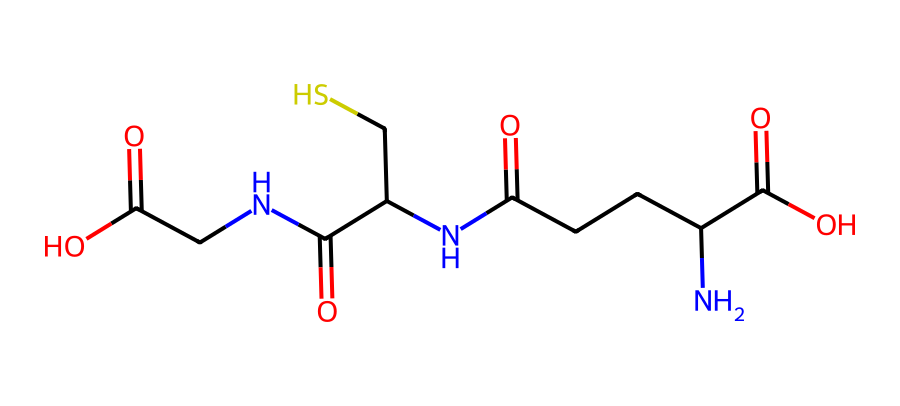What is the molecular formula of glutathione? By analyzing the structure represented by the SMILES, we can count the various types of atoms present: Carbon (C), Hydrogen (H), Nitrogen (N), Oxygen (O), and Sulfur (S). The total counts lead us to deduce the molecular formula.
Answer: C10H17N3O6S How many nitrogen atoms are present in glutathione? The structure includes three distinct nitrogen (N) atoms, identifiable from the amine functional groups.
Answer: 3 What type of functional groups are present in glutathione? Upon inspecting the structure, one can identify amine (-NH) groups and carboxylic acid (-COOH) groups, which are indicated by the presence of nitrogen and carbonyl oxygens connected to hydroxyl functions.
Answer: amine and carboxylic acid How many carbon atoms does glutathione contain? Counting the carbon (C) atoms in the structure reveals a total of ten carbon atoms, which can be visually confirmed in the chemical diagram derived from the SMILES representation.
Answer: 10 Is glutathione a peptide or a small protein? Glutathione is classified as a tripeptide, formed by the linkage of three amino acids through peptide bonds, which is characteristic of small proteins.
Answer: tripeptide What is the significance of sulfur in glutathione? The sulfur atom plays a crucial role in the antioxidant function of glutathione, enabling the formation of disulfide bonds, which are critical in redox reactions that protect cells from oxidative stress.
Answer: antioxidant function What is the primary antioxidant function of glutathione? Glutathione primarily acts to neutralize free radicals, thus preventing cellular damage caused by oxidative stress and maintaining redox homeostasis.
Answer: neutralize free radicals 